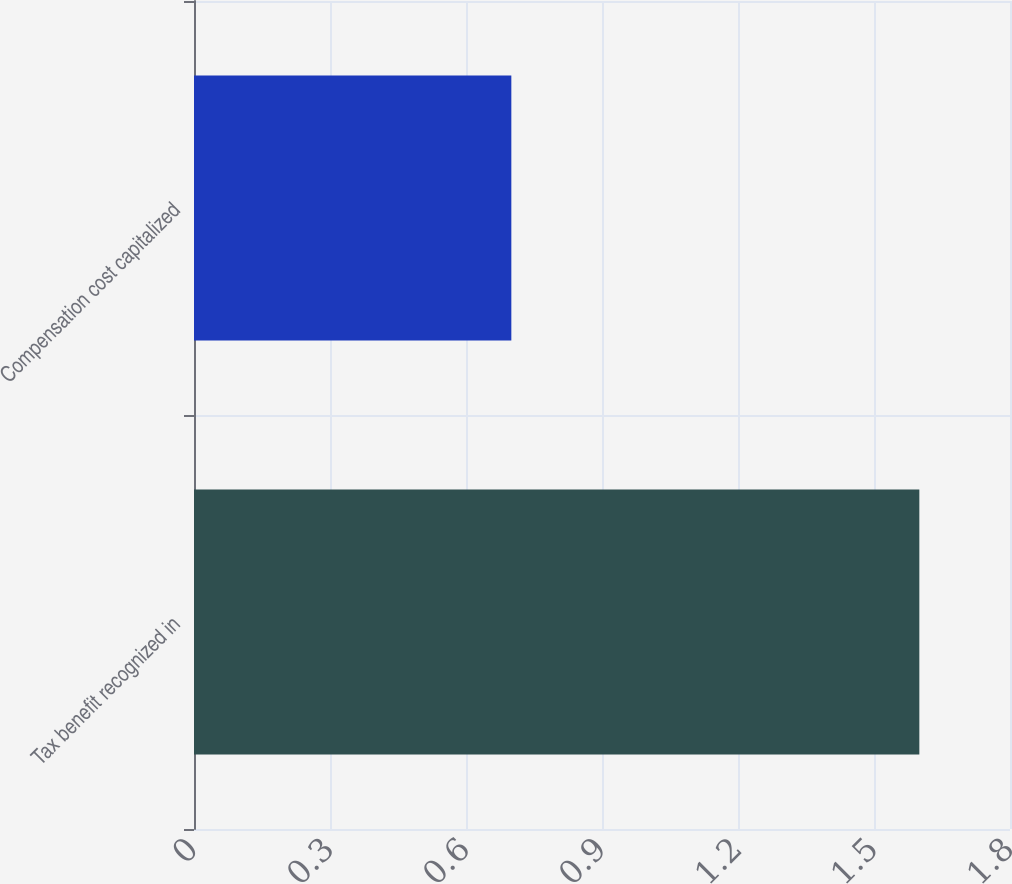Convert chart to OTSL. <chart><loc_0><loc_0><loc_500><loc_500><bar_chart><fcel>Tax benefit recognized in<fcel>Compensation cost capitalized<nl><fcel>1.6<fcel>0.7<nl></chart> 